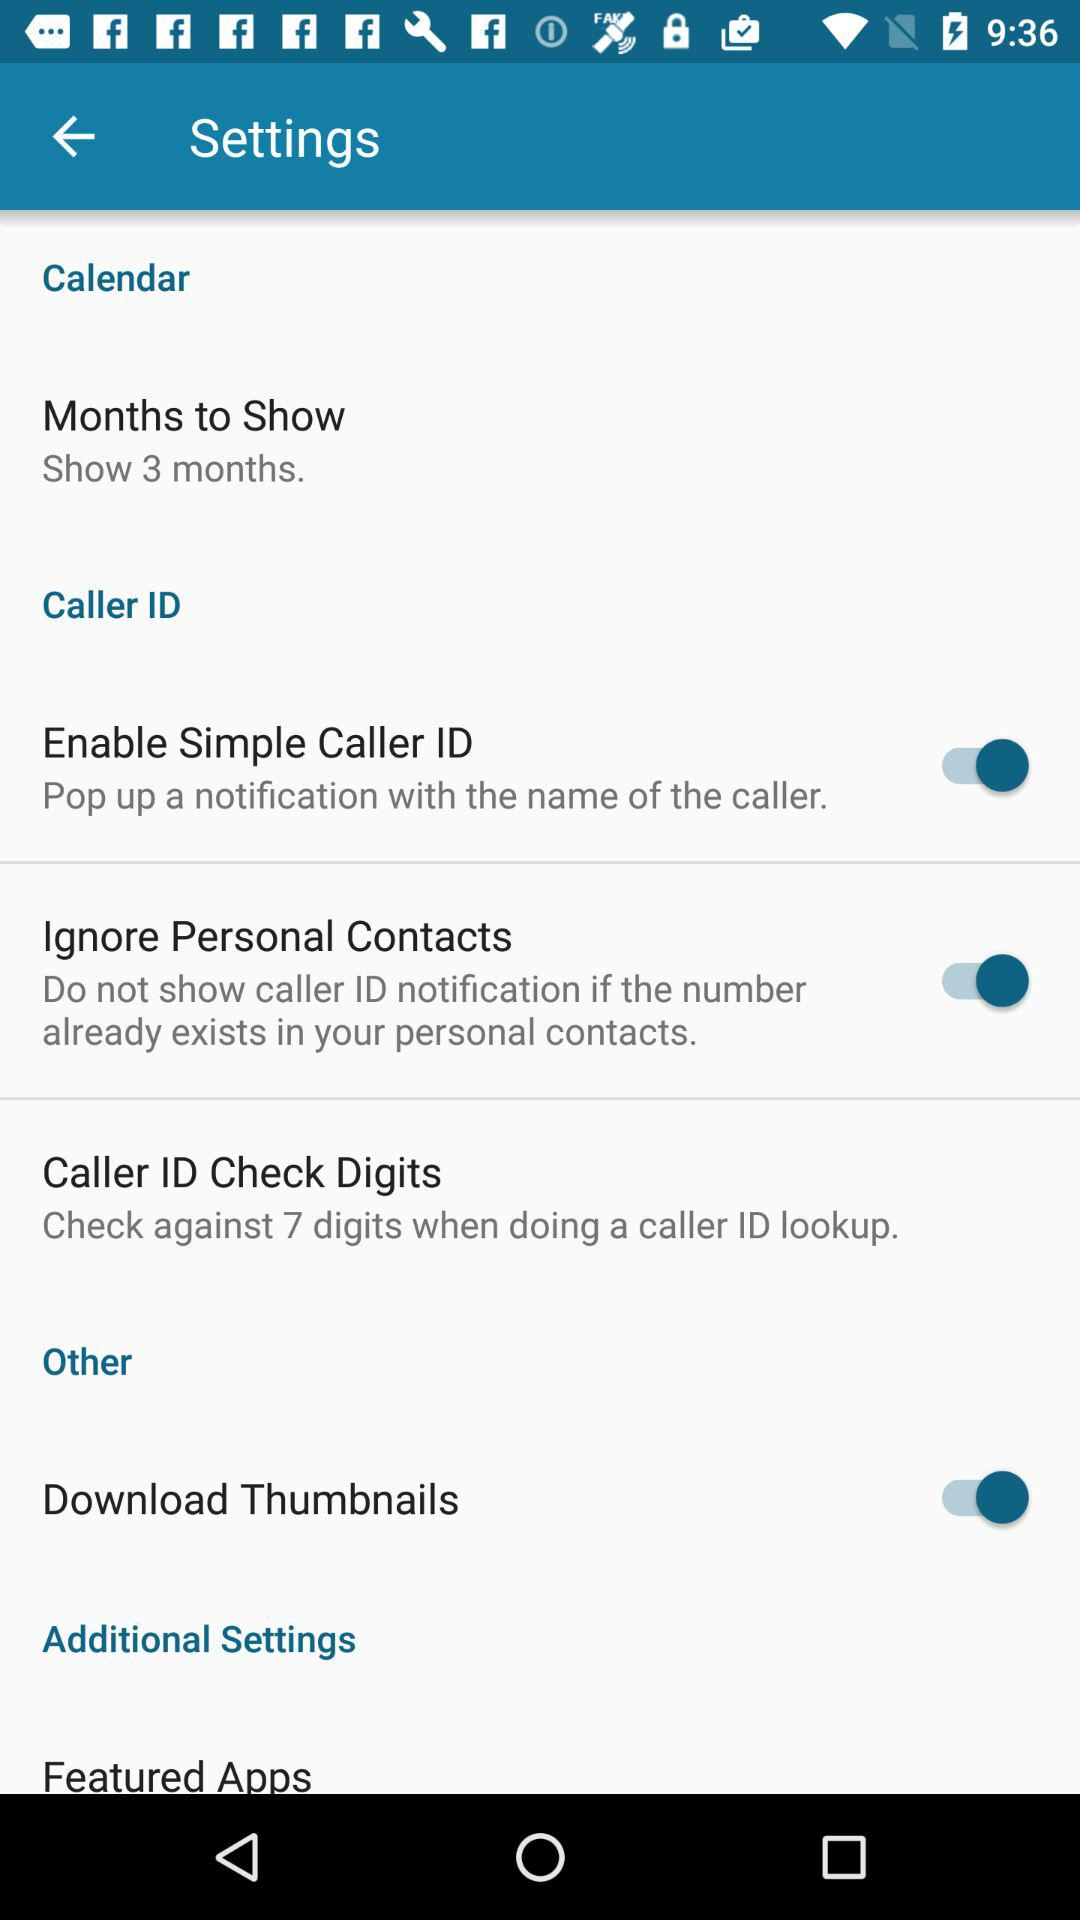What is the number of digits against which the caller ID needs to be checked while doing a lookup? The number of digits against which the caller ID needs to be checked while doing a lookup is 7. 